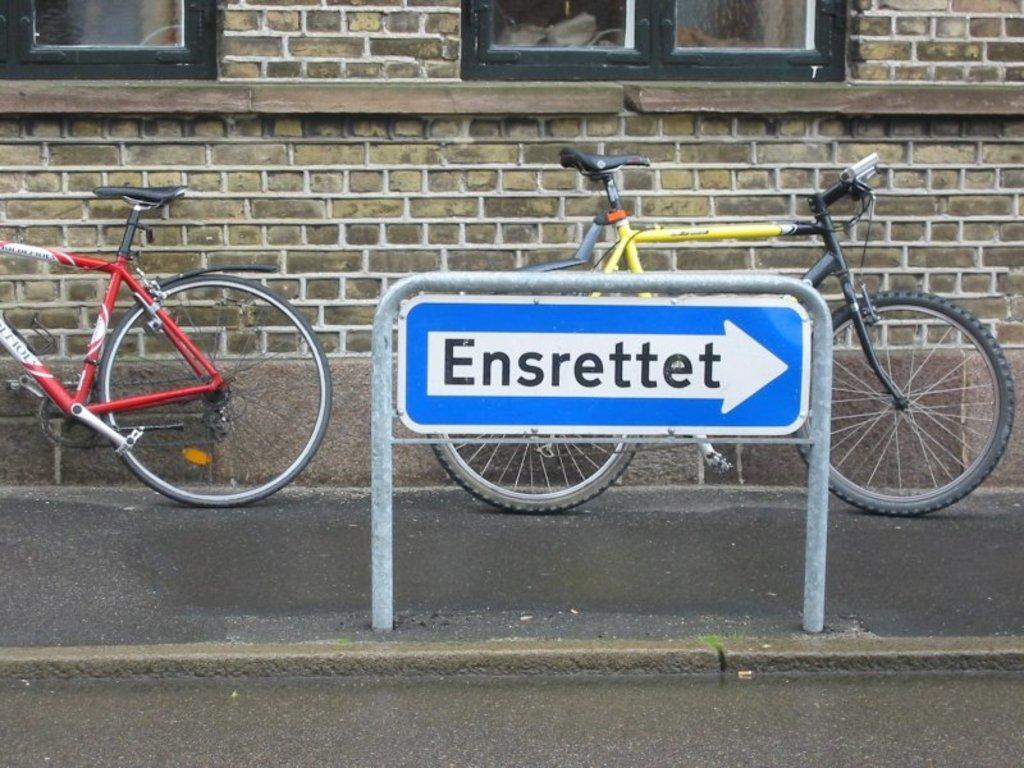Please provide a concise description of this image. In the picture I can see two bicycles and a board which has something written on it. I can also see a building which has windows. 